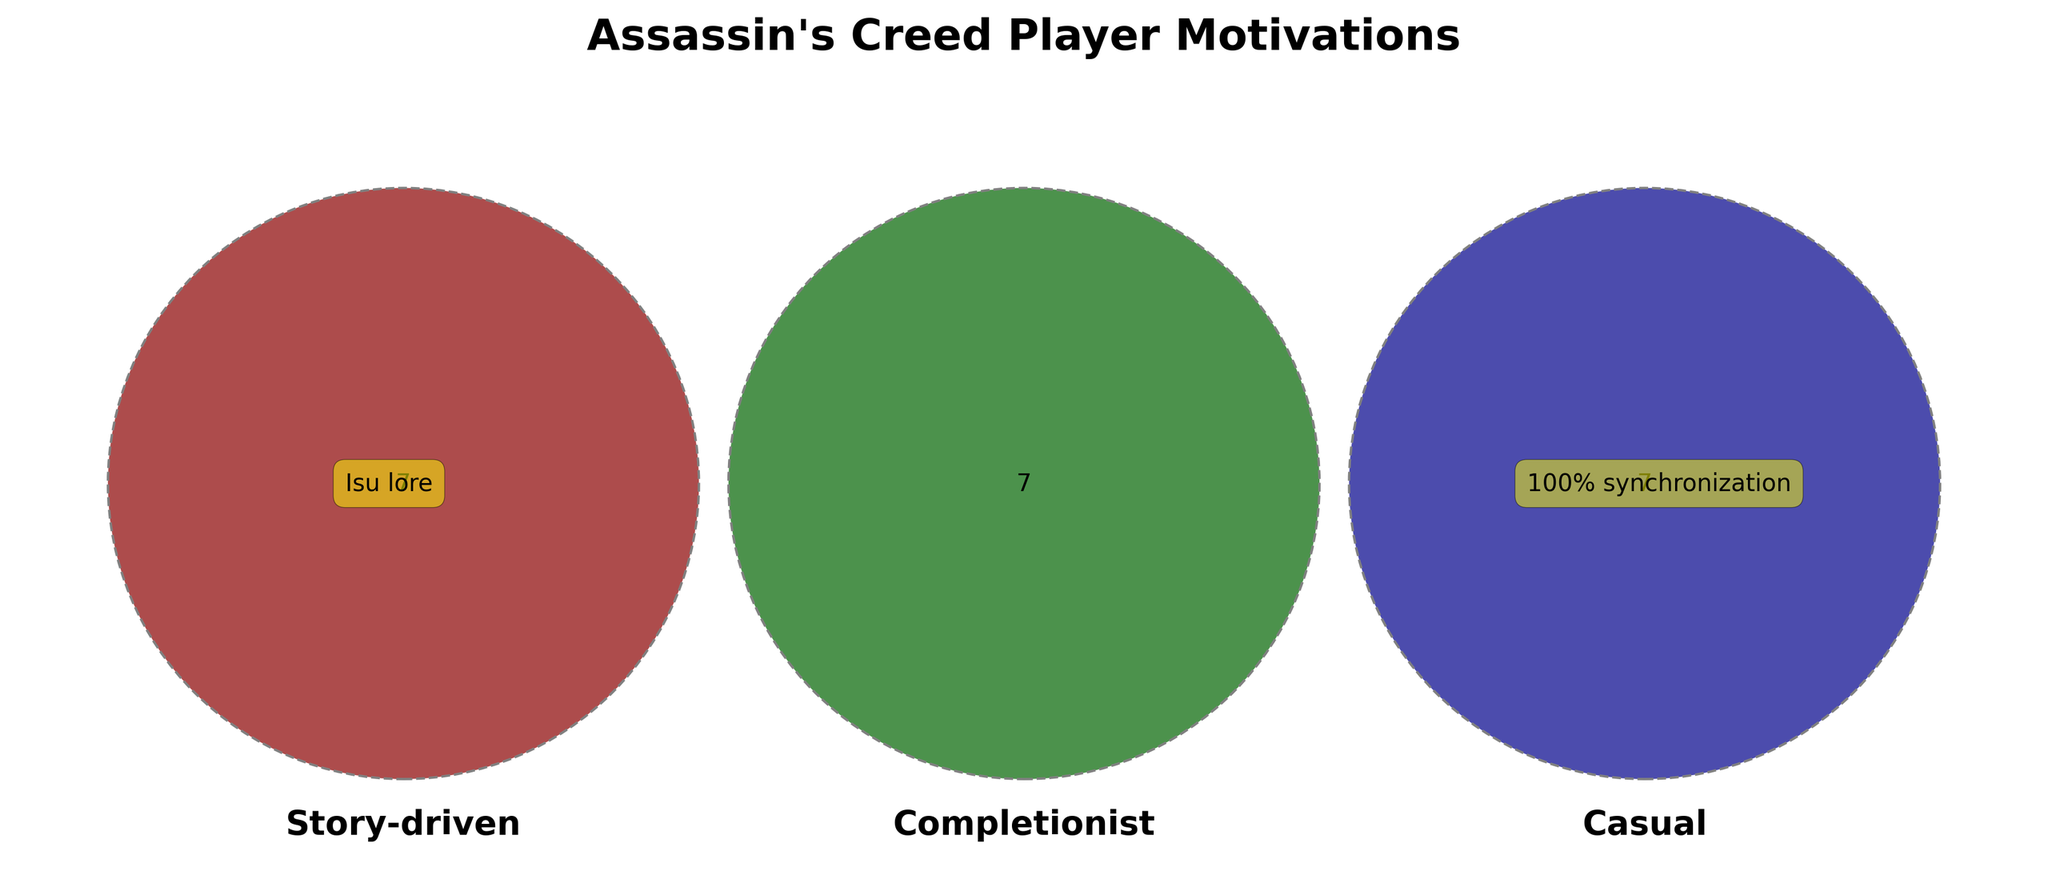What's the title of the Venn Diagram? The title of the Venn Diagram is displayed prominently at the top of the figure, helping viewers understand the main subject of the diagram.
Answer: Assassin's Creed Player Motivations What are the three main sets represented in the Venn Diagram? The Venn Diagram has three sets, each labeled with a specific term indicating the player motivations. These labels help categorize the motivations.
Answer: Story-driven, Completionist, Casual Which player motivation is represented by the color red in the Venn Diagram? The color of each set in the Venn Diagram helps to visually distinguish different categories. The set colored red represents one of these player motivations.
Answer: Story-driven What player activity is common in the Story-driven set only? Each section of the Venn Diagram represents unique or common activities for player motivations. We look at the section containing only the Story-driven category to find the specific activity listed.
Answer: Modern day plot Which activities are unique to the Casual set only? Each segment of the Venn Diagram shows the activities associated with one or more player motivations. By looking at the segment containing only the Casual activities, we can identify them.
Answer: Mobile games, Quick play sessions, Photo mode How many activities are exclusively listed in the Completionist set? The segments of the Venn Diagram corresponding to a single set show unique activities for that category. We count the activities listed in the Completionist-only segment.
Answer: Four What activities overlap between Story-driven and Completionist players? The overlapping sections of the Venn Diagram show common activities between different player motivations. We look at the intersection between the Story-driven and Completionist sets.
Answer: None Which activities are shared among all three player motivations (Story-driven, Completionist, and Casual)? The central part where all three sets intersect represents activities common to all three player motivations. By examining this section, we can identify the shared activities.
Answer: None What's the intersection between Completionist and Casual motivations? The overlapping segment of the Venn Diagram shows common activities between Completionist and Casual players. By examining this intersection, we identify the activities listed there.
Answer: None 